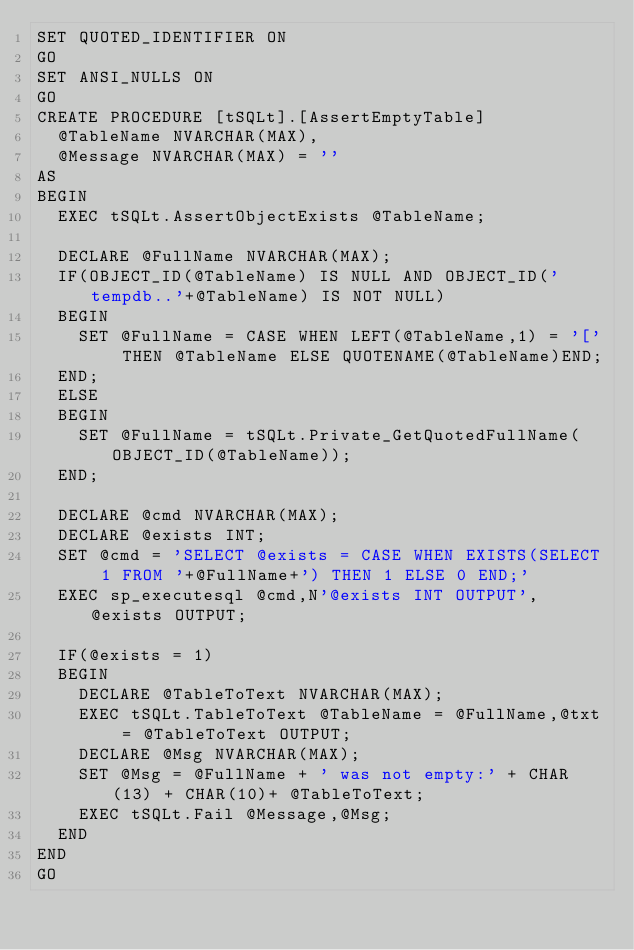Convert code to text. <code><loc_0><loc_0><loc_500><loc_500><_SQL_>SET QUOTED_IDENTIFIER ON
GO
SET ANSI_NULLS ON
GO
CREATE PROCEDURE [tSQLt].[AssertEmptyTable]
  @TableName NVARCHAR(MAX),
  @Message NVARCHAR(MAX) = ''
AS
BEGIN
  EXEC tSQLt.AssertObjectExists @TableName;

  DECLARE @FullName NVARCHAR(MAX);
  IF(OBJECT_ID(@TableName) IS NULL AND OBJECT_ID('tempdb..'+@TableName) IS NOT NULL)
  BEGIN
    SET @FullName = CASE WHEN LEFT(@TableName,1) = '[' THEN @TableName ELSE QUOTENAME(@TableName)END;
  END;
  ELSE
  BEGIN
    SET @FullName = tSQLt.Private_GetQuotedFullName(OBJECT_ID(@TableName));
  END;

  DECLARE @cmd NVARCHAR(MAX);
  DECLARE @exists INT;
  SET @cmd = 'SELECT @exists = CASE WHEN EXISTS(SELECT 1 FROM '+@FullName+') THEN 1 ELSE 0 END;'
  EXEC sp_executesql @cmd,N'@exists INT OUTPUT', @exists OUTPUT;
  
  IF(@exists = 1)
  BEGIN
    DECLARE @TableToText NVARCHAR(MAX);
    EXEC tSQLt.TableToText @TableName = @FullName,@txt = @TableToText OUTPUT;
    DECLARE @Msg NVARCHAR(MAX);
    SET @Msg = @FullName + ' was not empty:' + CHAR(13) + CHAR(10)+ @TableToText;
    EXEC tSQLt.Fail @Message,@Msg;
  END
END
GO
</code> 